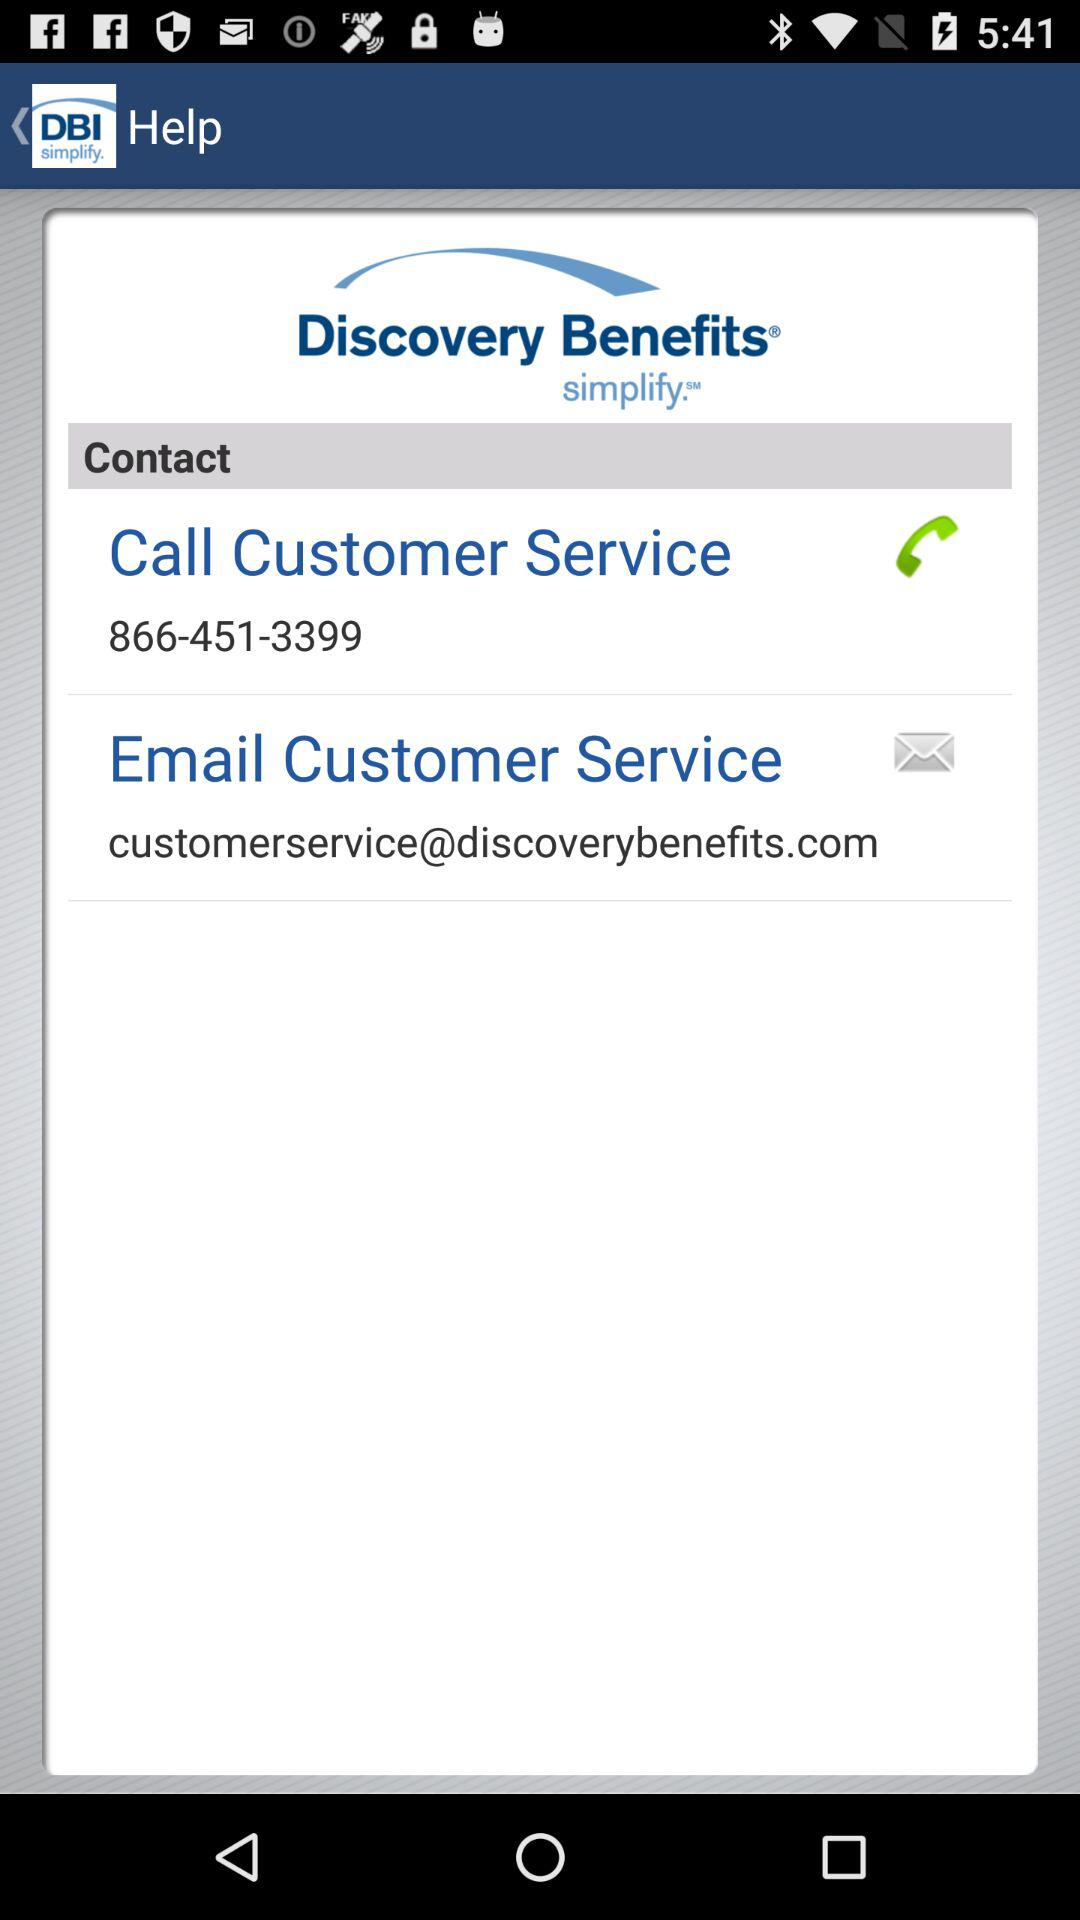What is the customer service number? The customer service number is 866-451-3399. 